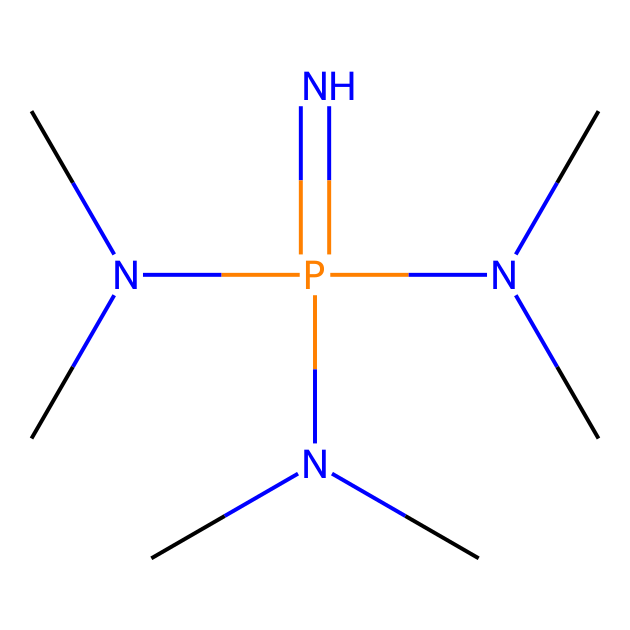What is the core atom in this chemical structure? The core atom is phosphorus, visually identifiable from the center of the structure where it is bonded to multiple nitrogen atoms.
Answer: phosphorus How many nitrogen atoms are present in the structure? There are four nitrogen atoms in the structure, as counted from the branching points where they are connected to the core phosphorus atom and the methyl groups.
Answer: four What functional groups are present in this molecule? The functional group in this molecule is the phosphazene group, indicated by the presence of alternating nitrogen and phosphorus atoms.
Answer: phosphazene What type of chemical reactivity might this molecule exhibit? It can act as a superbase due to the presence of lone pairs on the nitrogen atoms, which can accept protons, making it very basic.
Answer: superbase Which elements primarily compose this molecule? The primary elements are nitrogen, phosphorus, and carbon, as only these elements are visible in the SMILES representation.
Answer: nitrogen, phosphorus, carbon What property of phosphazenes makes them suitable for advanced polymer coatings? Their high basicity allows them to effectively react and stabilize in various polymer formulations, enhancing performance.
Answer: high basicity 